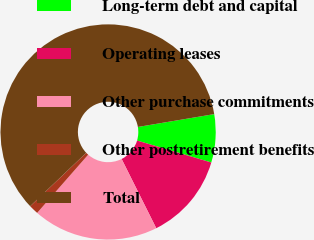Convert chart to OTSL. <chart><loc_0><loc_0><loc_500><loc_500><pie_chart><fcel>Long-term debt and capital<fcel>Operating leases<fcel>Other purchase commitments<fcel>Other postretirement benefits<fcel>Total<nl><fcel>7.23%<fcel>13.04%<fcel>18.84%<fcel>1.43%<fcel>59.46%<nl></chart> 